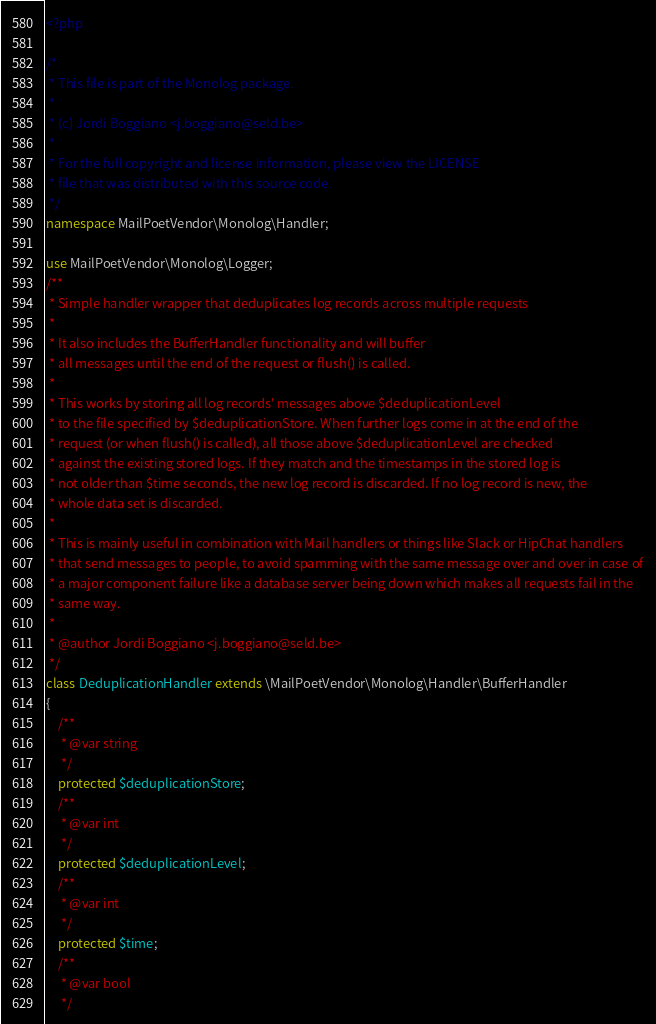<code> <loc_0><loc_0><loc_500><loc_500><_PHP_><?php

/*
 * This file is part of the Monolog package.
 *
 * (c) Jordi Boggiano <j.boggiano@seld.be>
 *
 * For the full copyright and license information, please view the LICENSE
 * file that was distributed with this source code.
 */
namespace MailPoetVendor\Monolog\Handler;

use MailPoetVendor\Monolog\Logger;
/**
 * Simple handler wrapper that deduplicates log records across multiple requests
 *
 * It also includes the BufferHandler functionality and will buffer
 * all messages until the end of the request or flush() is called.
 *
 * This works by storing all log records' messages above $deduplicationLevel
 * to the file specified by $deduplicationStore. When further logs come in at the end of the
 * request (or when flush() is called), all those above $deduplicationLevel are checked
 * against the existing stored logs. If they match and the timestamps in the stored log is
 * not older than $time seconds, the new log record is discarded. If no log record is new, the
 * whole data set is discarded.
 *
 * This is mainly useful in combination with Mail handlers or things like Slack or HipChat handlers
 * that send messages to people, to avoid spamming with the same message over and over in case of
 * a major component failure like a database server being down which makes all requests fail in the
 * same way.
 *
 * @author Jordi Boggiano <j.boggiano@seld.be>
 */
class DeduplicationHandler extends \MailPoetVendor\Monolog\Handler\BufferHandler
{
    /**
     * @var string
     */
    protected $deduplicationStore;
    /**
     * @var int
     */
    protected $deduplicationLevel;
    /**
     * @var int
     */
    protected $time;
    /**
     * @var bool
     */</code> 